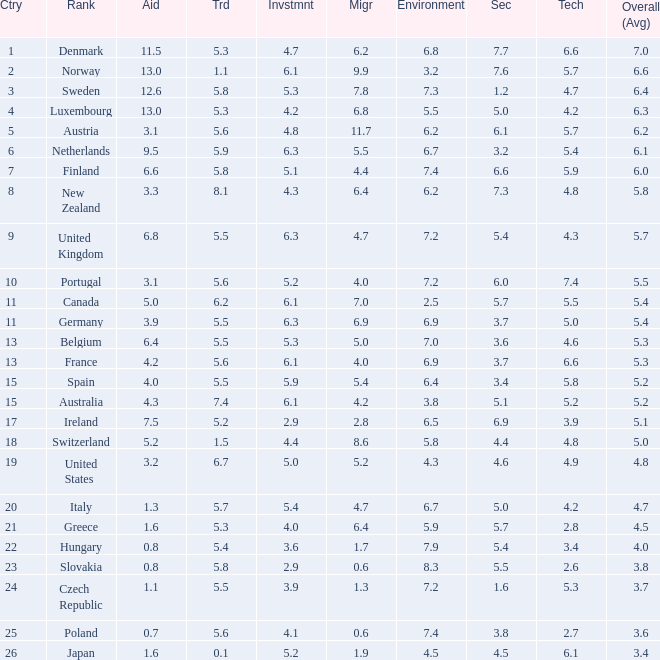What is the migration rating when trade is 5.7? 4.7. Can you parse all the data within this table? {'header': ['Ctry', 'Rank', 'Aid', 'Trd', 'Invstmnt', 'Migr', 'Environment', 'Sec', 'Tech', 'Overall (Avg)'], 'rows': [['1', 'Denmark', '11.5', '5.3', '4.7', '6.2', '6.8', '7.7', '6.6', '7.0'], ['2', 'Norway', '13.0', '1.1', '6.1', '9.9', '3.2', '7.6', '5.7', '6.6'], ['3', 'Sweden', '12.6', '5.8', '5.3', '7.8', '7.3', '1.2', '4.7', '6.4'], ['4', 'Luxembourg', '13.0', '5.3', '4.2', '6.8', '5.5', '5.0', '4.2', '6.3'], ['5', 'Austria', '3.1', '5.6', '4.8', '11.7', '6.2', '6.1', '5.7', '6.2'], ['6', 'Netherlands', '9.5', '5.9', '6.3', '5.5', '6.7', '3.2', '5.4', '6.1'], ['7', 'Finland', '6.6', '5.8', '5.1', '4.4', '7.4', '6.6', '5.9', '6.0'], ['8', 'New Zealand', '3.3', '8.1', '4.3', '6.4', '6.2', '7.3', '4.8', '5.8'], ['9', 'United Kingdom', '6.8', '5.5', '6.3', '4.7', '7.2', '5.4', '4.3', '5.7'], ['10', 'Portugal', '3.1', '5.6', '5.2', '4.0', '7.2', '6.0', '7.4', '5.5'], ['11', 'Canada', '5.0', '6.2', '6.1', '7.0', '2.5', '5.7', '5.5', '5.4'], ['11', 'Germany', '3.9', '5.5', '6.3', '6.9', '6.9', '3.7', '5.0', '5.4'], ['13', 'Belgium', '6.4', '5.5', '5.3', '5.0', '7.0', '3.6', '4.6', '5.3'], ['13', 'France', '4.2', '5.6', '6.1', '4.0', '6.9', '3.7', '6.6', '5.3'], ['15', 'Spain', '4.0', '5.5', '5.9', '5.4', '6.4', '3.4', '5.8', '5.2'], ['15', 'Australia', '4.3', '7.4', '6.1', '4.2', '3.8', '5.1', '5.2', '5.2'], ['17', 'Ireland', '7.5', '5.2', '2.9', '2.8', '6.5', '6.9', '3.9', '5.1'], ['18', 'Switzerland', '5.2', '1.5', '4.4', '8.6', '5.8', '4.4', '4.8', '5.0'], ['19', 'United States', '3.2', '6.7', '5.0', '5.2', '4.3', '4.6', '4.9', '4.8'], ['20', 'Italy', '1.3', '5.7', '5.4', '4.7', '6.7', '5.0', '4.2', '4.7'], ['21', 'Greece', '1.6', '5.3', '4.0', '6.4', '5.9', '5.7', '2.8', '4.5'], ['22', 'Hungary', '0.8', '5.4', '3.6', '1.7', '7.9', '5.4', '3.4', '4.0'], ['23', 'Slovakia', '0.8', '5.8', '2.9', '0.6', '8.3', '5.5', '2.6', '3.8'], ['24', 'Czech Republic', '1.1', '5.5', '3.9', '1.3', '7.2', '1.6', '5.3', '3.7'], ['25', 'Poland', '0.7', '5.6', '4.1', '0.6', '7.4', '3.8', '2.7', '3.6'], ['26', 'Japan', '1.6', '0.1', '5.2', '1.9', '4.5', '4.5', '6.1', '3.4']]} 